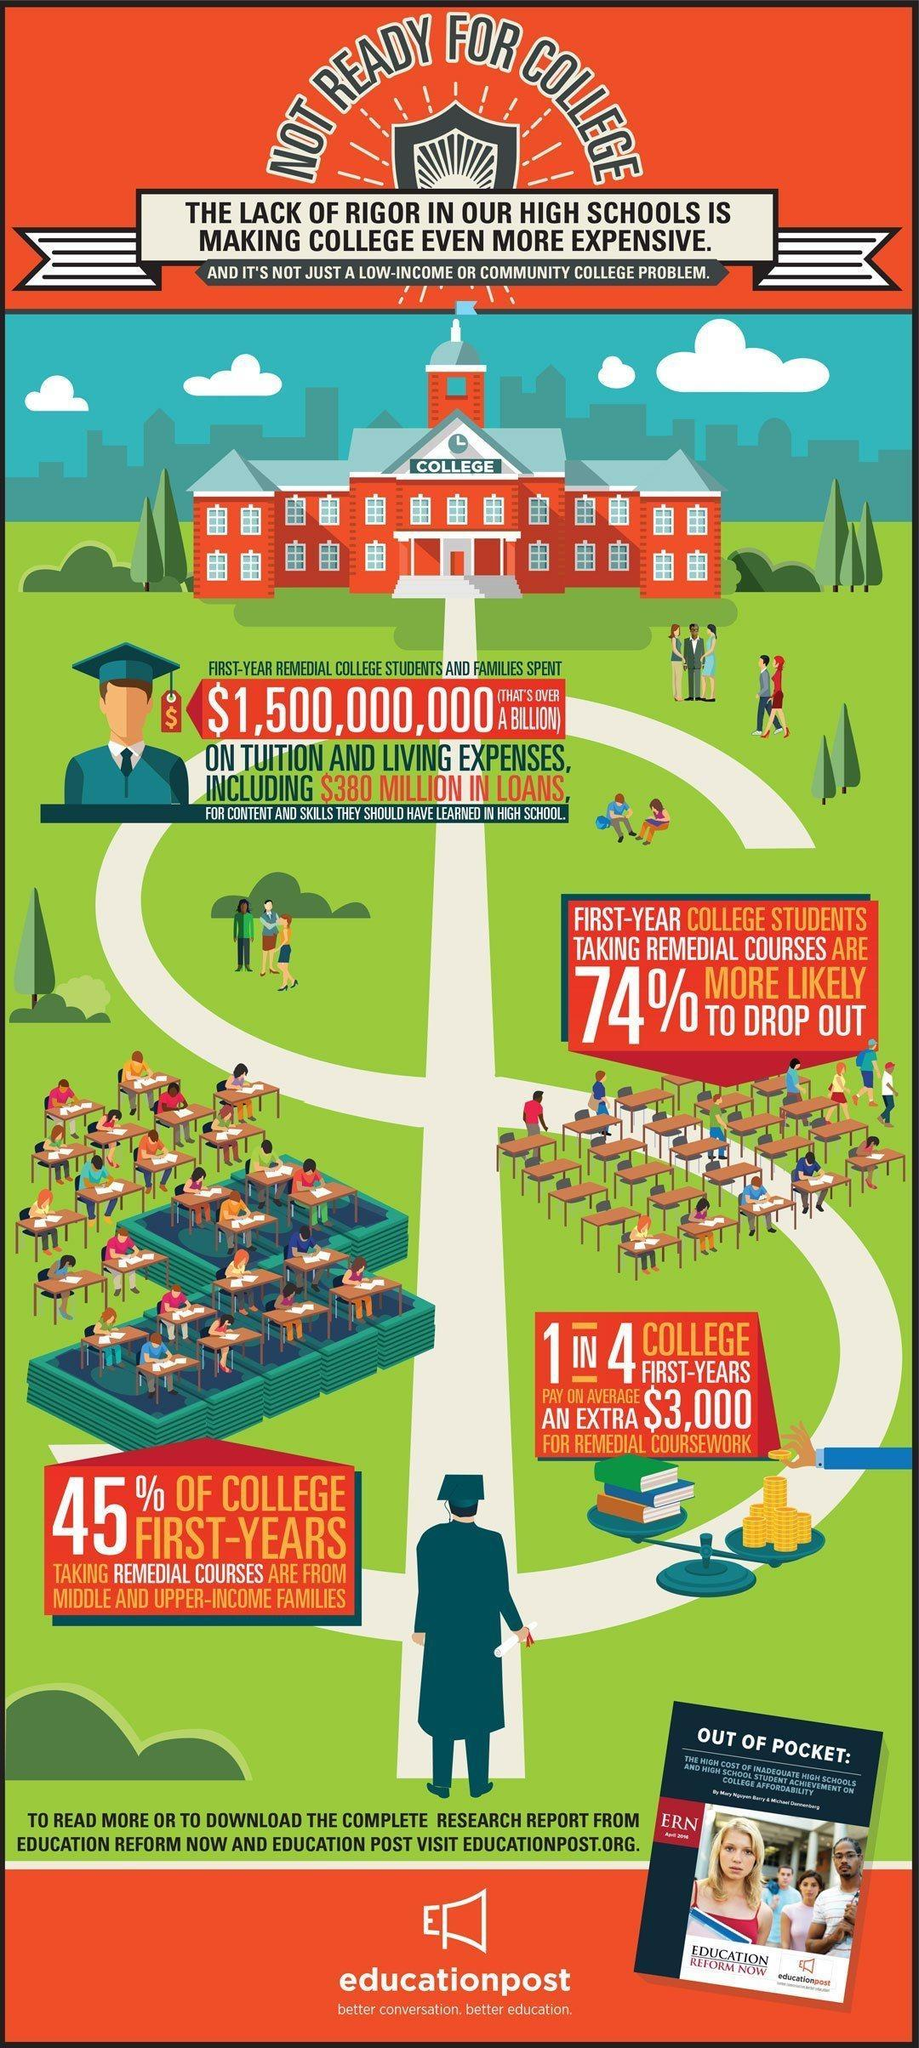How much was total amount taken in loans by college students and families?
Answer the question with a short phrase. $380 million Who had to spend over a billion dollars on tuition and living expenses? first-year remedial college students and families What percent of first-year students taking remedial classes are not likely to drop out? 26% What is the average amount spent on remedial coursework? $3,000 